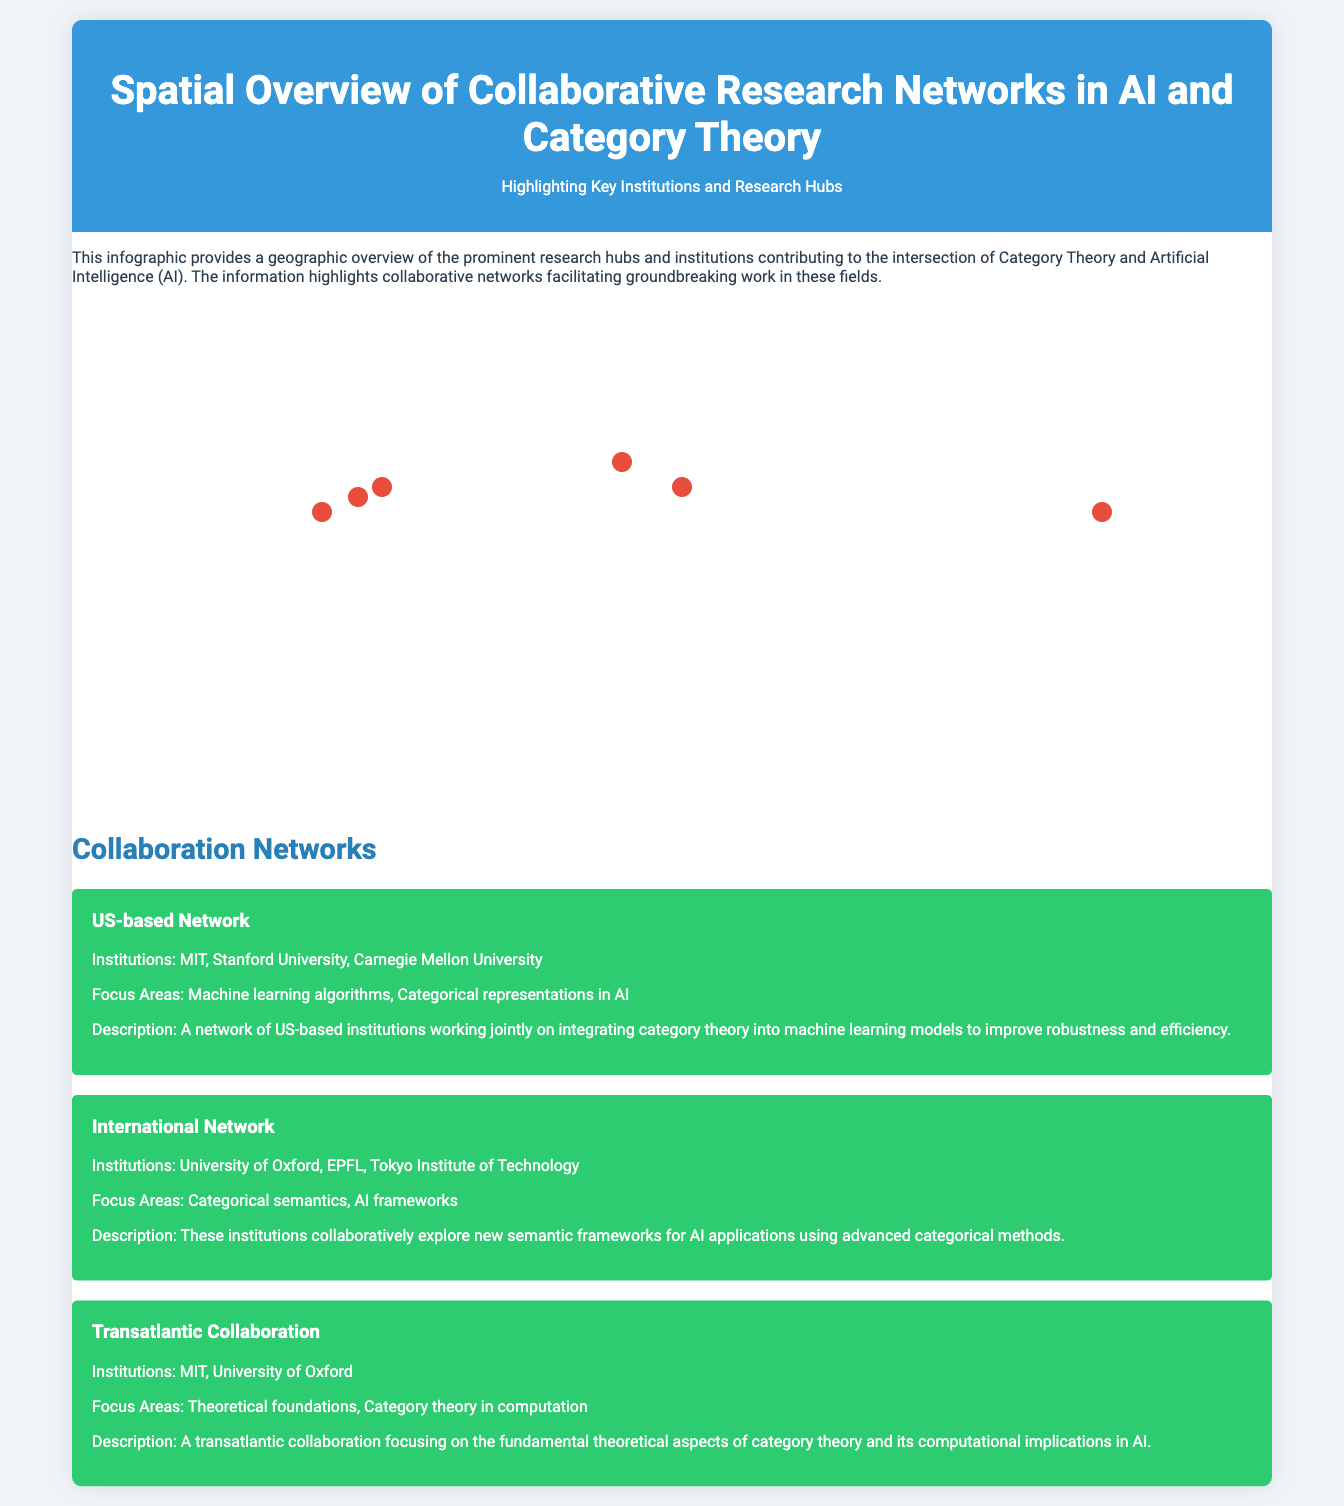What are the names of the institutions involved in the US-based Network? The US-based Network includes MIT, Stanford University, and Carnegie Mellon University.
Answer: MIT, Stanford University, Carnegie Mellon University What city is the University of Oxford located in? The city for the University of Oxford is mentioned as part of their institutional information in the document.
Answer: Oxford Which institution is associated with the Institute for AI and Category Theory? The document specifies that the Tokyo Institute of Technology has an Institute for AI and Category Theory.
Answer: Tokyo Institute of Technology How many key researchers are listed for Carnegie Mellon University? The document provides a count of key researchers associated with Carnegie Mellon University.
Answer: 2 What is the focus area of the International Network? The focus areas for the International Network are described in the collaboration section of the document.
Answer: Categorical semantics, AI frameworks Which university collaborates with MIT in a transatlantic partnership? The transatlantic collaboration with MIT includes the University of Oxford as specified in the network section.
Answer: University of Oxford What color represents the research hubs on the map? The document mentions the specific color that denotes research hubs in the infographic map design.
Answer: Red What is the main focus of collaboration mentioned for the US-based Network? The document describes the main collaboration focus areas within the US-based Network.
Answer: Machine learning algorithms, Categorical representations in AI 